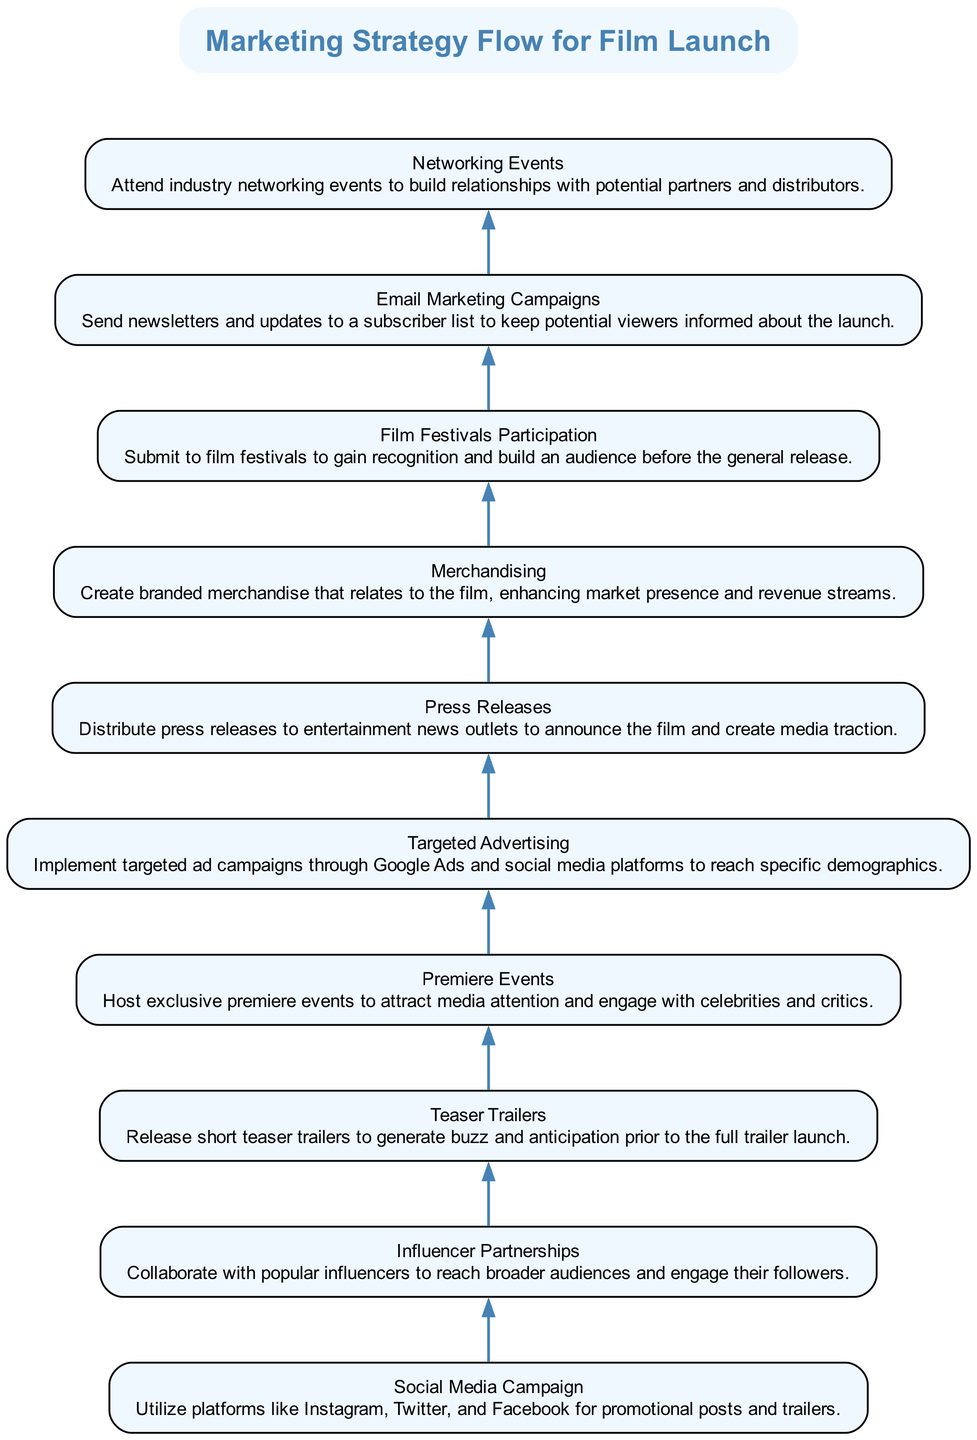What is the label of the first node? The first node in the diagram represents "Social Media Campaign," which is the initial step in the flow.
Answer: Social Media Campaign How many nodes are there in total? By counting each unique element represented in the diagram, there are ten nodes listed, each corresponding to a marketing strategy.
Answer: 10 What follows after "Email Marketing Campaigns"? The structure of the diagram shows that "Email Marketing Campaigns" is the last node, indicating there are no subsequent strategies following it.
Answer: None Which strategy is related to “Press Releases”? "Press Releases" is closely associated with generating media interest and is foundational for connecting to various promotional efforts like "Premiere Events" that follow in the flow.
Answer: Premiere Events What is the role of "Influencer Partnerships"? This node indicates that "Influencer Partnerships" is designed to expand reach and engage broader audiences, playing a pivotal part in the marketing strategy flow.
Answer: Expand reach What is the last strategy in the flow? The last node in the diagram represents "Email Marketing Campaigns," indicating the final step of the proposed marketing strategies for the film launch.
Answer: Email Marketing Campaigns What is the main purpose of the "Film Festivals Participation"? This node emphasizes the need to gain recognition and build an audience before the official launch, showcasing its importance in the marketing strategy.
Answer: Gain recognition What connection exists between “Targeted Advertising” and “Social Media Campaign”? "Targeted Advertising" follows "Social Media Campaign," indicating a sequential relationship where initial social media efforts lead into more specialized advertising strategies.
Answer: Sequential relationship What element enhances market presence and revenue streams? The node labeled "Merchandising" specifically pertains to creating branded merchandise which contributes to both market presence and potential revenue generation associated with the film.
Answer: Merchandising 